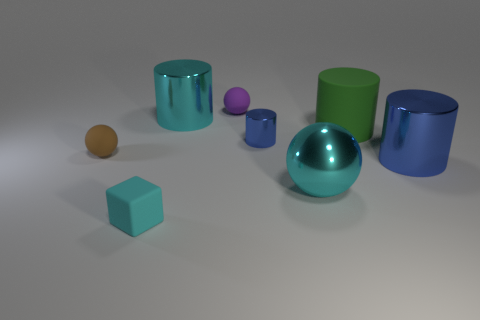Subtract all large cyan shiny cylinders. How many cylinders are left? 3 Add 1 big shiny spheres. How many objects exist? 9 Subtract all green cubes. How many blue cylinders are left? 2 Subtract all cyan balls. How many balls are left? 2 Subtract all balls. How many objects are left? 5 Subtract 2 blue cylinders. How many objects are left? 6 Subtract 2 cylinders. How many cylinders are left? 2 Subtract all yellow balls. Subtract all yellow cylinders. How many balls are left? 3 Subtract all tiny metal things. Subtract all big green objects. How many objects are left? 6 Add 8 big cyan objects. How many big cyan objects are left? 10 